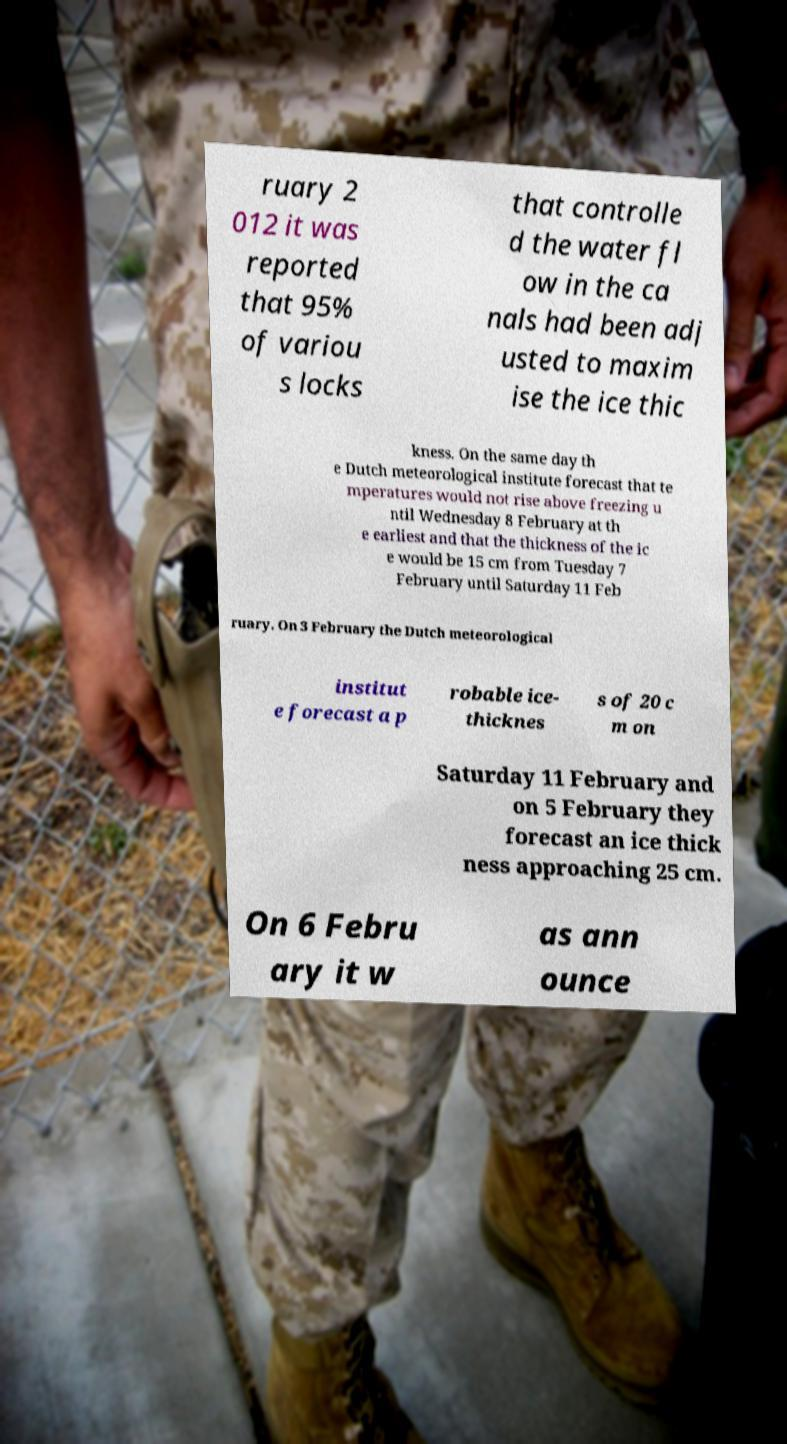Can you accurately transcribe the text from the provided image for me? ruary 2 012 it was reported that 95% of variou s locks that controlle d the water fl ow in the ca nals had been adj usted to maxim ise the ice thic kness. On the same day th e Dutch meteorological institute forecast that te mperatures would not rise above freezing u ntil Wednesday 8 February at th e earliest and that the thickness of the ic e would be 15 cm from Tuesday 7 February until Saturday 11 Feb ruary. On 3 February the Dutch meteorological institut e forecast a p robable ice- thicknes s of 20 c m on Saturday 11 February and on 5 February they forecast an ice thick ness approaching 25 cm. On 6 Febru ary it w as ann ounce 